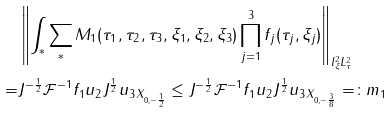<formula> <loc_0><loc_0><loc_500><loc_500>& \left \| \int _ { \ast } \sum _ { \ast } M _ { 1 } ( \tau _ { 1 } , \tau _ { 2 } , \tau _ { 3 } , \xi _ { 1 } , \xi _ { 2 } , \xi _ { 3 } ) \prod _ { j = 1 } ^ { 3 } f _ { j } ( \tau _ { j } , \xi _ { j } ) \right \| _ { l ^ { 2 } _ { \xi } L ^ { 2 } _ { \tau } } \\ = & \| J ^ { - \frac { 1 } { 2 } } \mathcal { F } ^ { - 1 } f _ { 1 } u _ { 2 } J ^ { \frac { 1 } { 2 } } u _ { 3 } \| _ { X _ { 0 , - \frac { 1 } { 2 } } } \leq \| J ^ { - \frac { 1 } { 2 } } \mathcal { F } ^ { - 1 } f _ { 1 } u _ { 2 } J ^ { \frac { 1 } { 2 } } u _ { 3 } \| _ { X _ { 0 , - \frac { 3 } { 8 } } } = \colon m _ { 1 }</formula> 